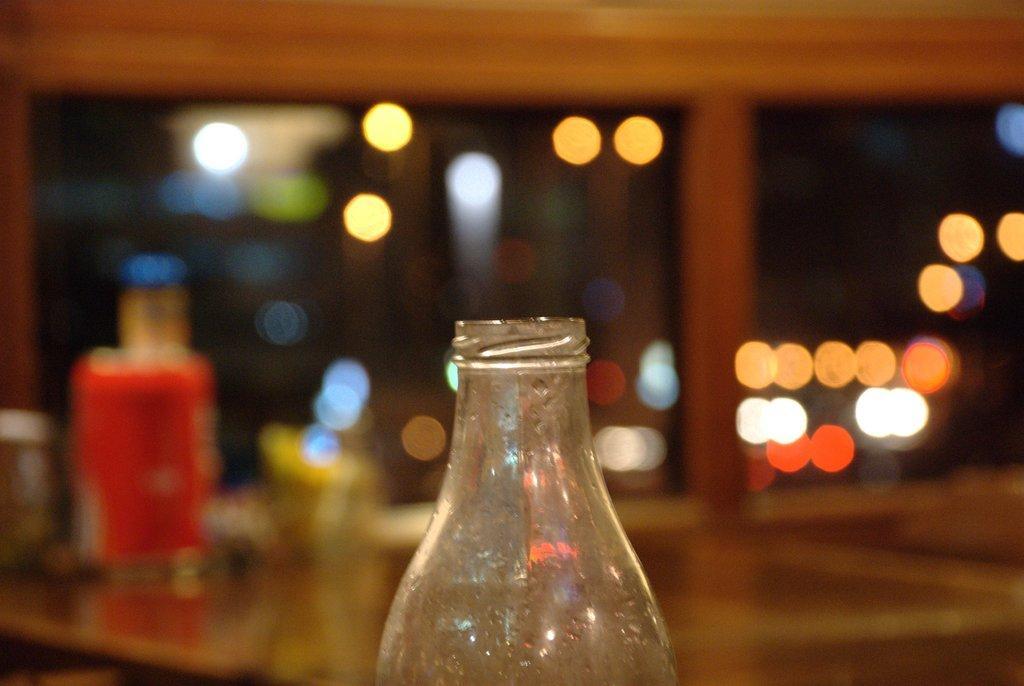How would you summarize this image in a sentence or two? In this image in the middle I can see a bottle. I can also see the background is blurred. 